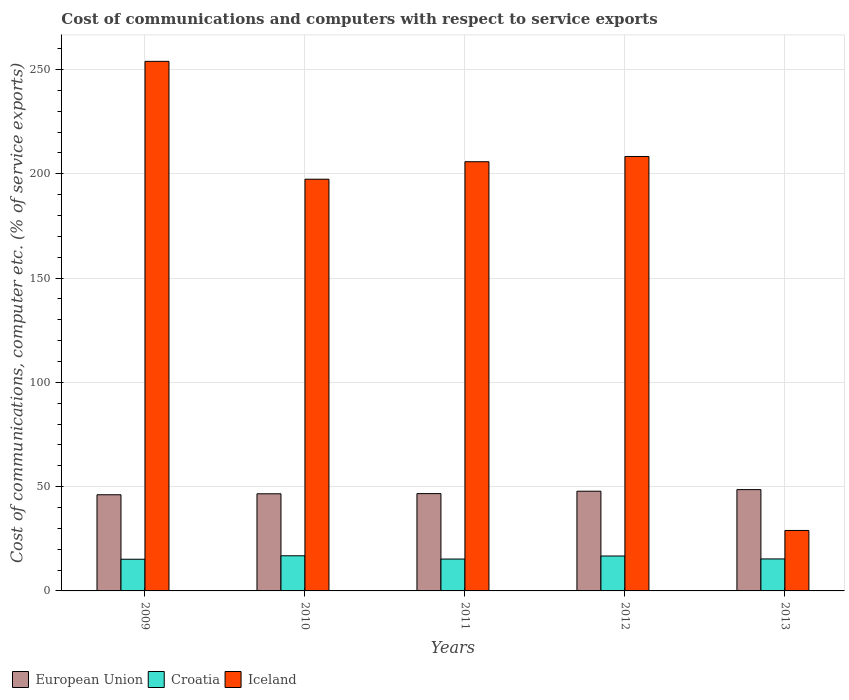How many different coloured bars are there?
Provide a short and direct response. 3. How many groups of bars are there?
Your answer should be very brief. 5. How many bars are there on the 5th tick from the left?
Your answer should be very brief. 3. What is the label of the 5th group of bars from the left?
Provide a short and direct response. 2013. What is the cost of communications and computers in Iceland in 2011?
Ensure brevity in your answer.  205.78. Across all years, what is the maximum cost of communications and computers in Iceland?
Keep it short and to the point. 253.9. Across all years, what is the minimum cost of communications and computers in Iceland?
Offer a very short reply. 28.99. In which year was the cost of communications and computers in Croatia minimum?
Offer a terse response. 2009. What is the total cost of communications and computers in European Union in the graph?
Provide a short and direct response. 235.71. What is the difference between the cost of communications and computers in European Union in 2010 and that in 2012?
Provide a short and direct response. -1.24. What is the difference between the cost of communications and computers in Iceland in 2010 and the cost of communications and computers in Croatia in 2009?
Ensure brevity in your answer.  182.21. What is the average cost of communications and computers in Croatia per year?
Your response must be concise. 15.88. In the year 2012, what is the difference between the cost of communications and computers in Iceland and cost of communications and computers in Croatia?
Provide a succinct answer. 191.56. What is the ratio of the cost of communications and computers in Croatia in 2010 to that in 2012?
Give a very brief answer. 1.01. Is the difference between the cost of communications and computers in Iceland in 2010 and 2011 greater than the difference between the cost of communications and computers in Croatia in 2010 and 2011?
Keep it short and to the point. No. What is the difference between the highest and the second highest cost of communications and computers in Croatia?
Give a very brief answer. 0.11. What is the difference between the highest and the lowest cost of communications and computers in Croatia?
Offer a terse response. 1.66. What does the 2nd bar from the right in 2011 represents?
Keep it short and to the point. Croatia. How many bars are there?
Offer a very short reply. 15. Are all the bars in the graph horizontal?
Your answer should be very brief. No. How many years are there in the graph?
Offer a terse response. 5. Does the graph contain any zero values?
Provide a short and direct response. No. How many legend labels are there?
Your answer should be compact. 3. What is the title of the graph?
Give a very brief answer. Cost of communications and computers with respect to service exports. Does "Madagascar" appear as one of the legend labels in the graph?
Your response must be concise. No. What is the label or title of the Y-axis?
Provide a short and direct response. Cost of communications, computer etc. (% of service exports). What is the Cost of communications, computer etc. (% of service exports) of European Union in 2009?
Provide a succinct answer. 46.11. What is the Cost of communications, computer etc. (% of service exports) in Croatia in 2009?
Your answer should be compact. 15.19. What is the Cost of communications, computer etc. (% of service exports) of Iceland in 2009?
Your response must be concise. 253.9. What is the Cost of communications, computer etc. (% of service exports) of European Union in 2010?
Offer a terse response. 46.57. What is the Cost of communications, computer etc. (% of service exports) of Croatia in 2010?
Give a very brief answer. 16.85. What is the Cost of communications, computer etc. (% of service exports) in Iceland in 2010?
Keep it short and to the point. 197.4. What is the Cost of communications, computer etc. (% of service exports) in European Union in 2011?
Offer a terse response. 46.65. What is the Cost of communications, computer etc. (% of service exports) in Croatia in 2011?
Ensure brevity in your answer.  15.28. What is the Cost of communications, computer etc. (% of service exports) in Iceland in 2011?
Keep it short and to the point. 205.78. What is the Cost of communications, computer etc. (% of service exports) of European Union in 2012?
Your answer should be very brief. 47.81. What is the Cost of communications, computer etc. (% of service exports) in Croatia in 2012?
Keep it short and to the point. 16.74. What is the Cost of communications, computer etc. (% of service exports) of Iceland in 2012?
Your answer should be compact. 208.3. What is the Cost of communications, computer etc. (% of service exports) in European Union in 2013?
Give a very brief answer. 48.57. What is the Cost of communications, computer etc. (% of service exports) in Croatia in 2013?
Ensure brevity in your answer.  15.34. What is the Cost of communications, computer etc. (% of service exports) in Iceland in 2013?
Your response must be concise. 28.99. Across all years, what is the maximum Cost of communications, computer etc. (% of service exports) in European Union?
Your answer should be very brief. 48.57. Across all years, what is the maximum Cost of communications, computer etc. (% of service exports) of Croatia?
Your response must be concise. 16.85. Across all years, what is the maximum Cost of communications, computer etc. (% of service exports) in Iceland?
Give a very brief answer. 253.9. Across all years, what is the minimum Cost of communications, computer etc. (% of service exports) in European Union?
Provide a short and direct response. 46.11. Across all years, what is the minimum Cost of communications, computer etc. (% of service exports) in Croatia?
Keep it short and to the point. 15.19. Across all years, what is the minimum Cost of communications, computer etc. (% of service exports) in Iceland?
Offer a terse response. 28.99. What is the total Cost of communications, computer etc. (% of service exports) in European Union in the graph?
Keep it short and to the point. 235.71. What is the total Cost of communications, computer etc. (% of service exports) in Croatia in the graph?
Provide a short and direct response. 79.39. What is the total Cost of communications, computer etc. (% of service exports) in Iceland in the graph?
Give a very brief answer. 894.36. What is the difference between the Cost of communications, computer etc. (% of service exports) in European Union in 2009 and that in 2010?
Offer a terse response. -0.46. What is the difference between the Cost of communications, computer etc. (% of service exports) of Croatia in 2009 and that in 2010?
Your response must be concise. -1.66. What is the difference between the Cost of communications, computer etc. (% of service exports) of Iceland in 2009 and that in 2010?
Offer a terse response. 56.51. What is the difference between the Cost of communications, computer etc. (% of service exports) of European Union in 2009 and that in 2011?
Give a very brief answer. -0.54. What is the difference between the Cost of communications, computer etc. (% of service exports) of Croatia in 2009 and that in 2011?
Ensure brevity in your answer.  -0.09. What is the difference between the Cost of communications, computer etc. (% of service exports) in Iceland in 2009 and that in 2011?
Your response must be concise. 48.12. What is the difference between the Cost of communications, computer etc. (% of service exports) of European Union in 2009 and that in 2012?
Your answer should be very brief. -1.7. What is the difference between the Cost of communications, computer etc. (% of service exports) of Croatia in 2009 and that in 2012?
Your answer should be compact. -1.55. What is the difference between the Cost of communications, computer etc. (% of service exports) in Iceland in 2009 and that in 2012?
Ensure brevity in your answer.  45.6. What is the difference between the Cost of communications, computer etc. (% of service exports) of European Union in 2009 and that in 2013?
Your response must be concise. -2.46. What is the difference between the Cost of communications, computer etc. (% of service exports) in Croatia in 2009 and that in 2013?
Provide a succinct answer. -0.15. What is the difference between the Cost of communications, computer etc. (% of service exports) in Iceland in 2009 and that in 2013?
Offer a terse response. 224.91. What is the difference between the Cost of communications, computer etc. (% of service exports) in European Union in 2010 and that in 2011?
Provide a short and direct response. -0.08. What is the difference between the Cost of communications, computer etc. (% of service exports) in Croatia in 2010 and that in 2011?
Your response must be concise. 1.58. What is the difference between the Cost of communications, computer etc. (% of service exports) in Iceland in 2010 and that in 2011?
Your answer should be compact. -8.38. What is the difference between the Cost of communications, computer etc. (% of service exports) of European Union in 2010 and that in 2012?
Give a very brief answer. -1.24. What is the difference between the Cost of communications, computer etc. (% of service exports) of Croatia in 2010 and that in 2012?
Make the answer very short. 0.11. What is the difference between the Cost of communications, computer etc. (% of service exports) in Iceland in 2010 and that in 2012?
Provide a succinct answer. -10.9. What is the difference between the Cost of communications, computer etc. (% of service exports) of European Union in 2010 and that in 2013?
Ensure brevity in your answer.  -1.99. What is the difference between the Cost of communications, computer etc. (% of service exports) of Croatia in 2010 and that in 2013?
Give a very brief answer. 1.52. What is the difference between the Cost of communications, computer etc. (% of service exports) in Iceland in 2010 and that in 2013?
Keep it short and to the point. 168.41. What is the difference between the Cost of communications, computer etc. (% of service exports) in European Union in 2011 and that in 2012?
Provide a short and direct response. -1.16. What is the difference between the Cost of communications, computer etc. (% of service exports) of Croatia in 2011 and that in 2012?
Your answer should be compact. -1.46. What is the difference between the Cost of communications, computer etc. (% of service exports) of Iceland in 2011 and that in 2012?
Your response must be concise. -2.52. What is the difference between the Cost of communications, computer etc. (% of service exports) of European Union in 2011 and that in 2013?
Provide a short and direct response. -1.92. What is the difference between the Cost of communications, computer etc. (% of service exports) of Croatia in 2011 and that in 2013?
Make the answer very short. -0.06. What is the difference between the Cost of communications, computer etc. (% of service exports) in Iceland in 2011 and that in 2013?
Offer a terse response. 176.79. What is the difference between the Cost of communications, computer etc. (% of service exports) of European Union in 2012 and that in 2013?
Your response must be concise. -0.76. What is the difference between the Cost of communications, computer etc. (% of service exports) in Croatia in 2012 and that in 2013?
Offer a terse response. 1.4. What is the difference between the Cost of communications, computer etc. (% of service exports) of Iceland in 2012 and that in 2013?
Provide a short and direct response. 179.31. What is the difference between the Cost of communications, computer etc. (% of service exports) of European Union in 2009 and the Cost of communications, computer etc. (% of service exports) of Croatia in 2010?
Offer a very short reply. 29.26. What is the difference between the Cost of communications, computer etc. (% of service exports) of European Union in 2009 and the Cost of communications, computer etc. (% of service exports) of Iceland in 2010?
Your answer should be very brief. -151.29. What is the difference between the Cost of communications, computer etc. (% of service exports) of Croatia in 2009 and the Cost of communications, computer etc. (% of service exports) of Iceland in 2010?
Keep it short and to the point. -182.21. What is the difference between the Cost of communications, computer etc. (% of service exports) in European Union in 2009 and the Cost of communications, computer etc. (% of service exports) in Croatia in 2011?
Give a very brief answer. 30.83. What is the difference between the Cost of communications, computer etc. (% of service exports) of European Union in 2009 and the Cost of communications, computer etc. (% of service exports) of Iceland in 2011?
Offer a terse response. -159.67. What is the difference between the Cost of communications, computer etc. (% of service exports) in Croatia in 2009 and the Cost of communications, computer etc. (% of service exports) in Iceland in 2011?
Offer a terse response. -190.59. What is the difference between the Cost of communications, computer etc. (% of service exports) in European Union in 2009 and the Cost of communications, computer etc. (% of service exports) in Croatia in 2012?
Make the answer very short. 29.37. What is the difference between the Cost of communications, computer etc. (% of service exports) of European Union in 2009 and the Cost of communications, computer etc. (% of service exports) of Iceland in 2012?
Keep it short and to the point. -162.19. What is the difference between the Cost of communications, computer etc. (% of service exports) in Croatia in 2009 and the Cost of communications, computer etc. (% of service exports) in Iceland in 2012?
Your answer should be very brief. -193.11. What is the difference between the Cost of communications, computer etc. (% of service exports) of European Union in 2009 and the Cost of communications, computer etc. (% of service exports) of Croatia in 2013?
Give a very brief answer. 30.77. What is the difference between the Cost of communications, computer etc. (% of service exports) of European Union in 2009 and the Cost of communications, computer etc. (% of service exports) of Iceland in 2013?
Provide a succinct answer. 17.12. What is the difference between the Cost of communications, computer etc. (% of service exports) in Croatia in 2009 and the Cost of communications, computer etc. (% of service exports) in Iceland in 2013?
Your answer should be compact. -13.8. What is the difference between the Cost of communications, computer etc. (% of service exports) of European Union in 2010 and the Cost of communications, computer etc. (% of service exports) of Croatia in 2011?
Offer a very short reply. 31.3. What is the difference between the Cost of communications, computer etc. (% of service exports) of European Union in 2010 and the Cost of communications, computer etc. (% of service exports) of Iceland in 2011?
Offer a very short reply. -159.2. What is the difference between the Cost of communications, computer etc. (% of service exports) of Croatia in 2010 and the Cost of communications, computer etc. (% of service exports) of Iceland in 2011?
Your answer should be compact. -188.92. What is the difference between the Cost of communications, computer etc. (% of service exports) of European Union in 2010 and the Cost of communications, computer etc. (% of service exports) of Croatia in 2012?
Your response must be concise. 29.83. What is the difference between the Cost of communications, computer etc. (% of service exports) of European Union in 2010 and the Cost of communications, computer etc. (% of service exports) of Iceland in 2012?
Your answer should be very brief. -161.72. What is the difference between the Cost of communications, computer etc. (% of service exports) in Croatia in 2010 and the Cost of communications, computer etc. (% of service exports) in Iceland in 2012?
Offer a terse response. -191.45. What is the difference between the Cost of communications, computer etc. (% of service exports) in European Union in 2010 and the Cost of communications, computer etc. (% of service exports) in Croatia in 2013?
Ensure brevity in your answer.  31.24. What is the difference between the Cost of communications, computer etc. (% of service exports) in European Union in 2010 and the Cost of communications, computer etc. (% of service exports) in Iceland in 2013?
Your answer should be very brief. 17.58. What is the difference between the Cost of communications, computer etc. (% of service exports) in Croatia in 2010 and the Cost of communications, computer etc. (% of service exports) in Iceland in 2013?
Your answer should be very brief. -12.14. What is the difference between the Cost of communications, computer etc. (% of service exports) in European Union in 2011 and the Cost of communications, computer etc. (% of service exports) in Croatia in 2012?
Offer a terse response. 29.91. What is the difference between the Cost of communications, computer etc. (% of service exports) in European Union in 2011 and the Cost of communications, computer etc. (% of service exports) in Iceland in 2012?
Ensure brevity in your answer.  -161.65. What is the difference between the Cost of communications, computer etc. (% of service exports) in Croatia in 2011 and the Cost of communications, computer etc. (% of service exports) in Iceland in 2012?
Provide a short and direct response. -193.02. What is the difference between the Cost of communications, computer etc. (% of service exports) of European Union in 2011 and the Cost of communications, computer etc. (% of service exports) of Croatia in 2013?
Ensure brevity in your answer.  31.32. What is the difference between the Cost of communications, computer etc. (% of service exports) of European Union in 2011 and the Cost of communications, computer etc. (% of service exports) of Iceland in 2013?
Make the answer very short. 17.66. What is the difference between the Cost of communications, computer etc. (% of service exports) of Croatia in 2011 and the Cost of communications, computer etc. (% of service exports) of Iceland in 2013?
Make the answer very short. -13.71. What is the difference between the Cost of communications, computer etc. (% of service exports) in European Union in 2012 and the Cost of communications, computer etc. (% of service exports) in Croatia in 2013?
Ensure brevity in your answer.  32.47. What is the difference between the Cost of communications, computer etc. (% of service exports) of European Union in 2012 and the Cost of communications, computer etc. (% of service exports) of Iceland in 2013?
Ensure brevity in your answer.  18.82. What is the difference between the Cost of communications, computer etc. (% of service exports) in Croatia in 2012 and the Cost of communications, computer etc. (% of service exports) in Iceland in 2013?
Your response must be concise. -12.25. What is the average Cost of communications, computer etc. (% of service exports) of European Union per year?
Give a very brief answer. 47.14. What is the average Cost of communications, computer etc. (% of service exports) in Croatia per year?
Ensure brevity in your answer.  15.88. What is the average Cost of communications, computer etc. (% of service exports) of Iceland per year?
Your response must be concise. 178.87. In the year 2009, what is the difference between the Cost of communications, computer etc. (% of service exports) in European Union and Cost of communications, computer etc. (% of service exports) in Croatia?
Keep it short and to the point. 30.92. In the year 2009, what is the difference between the Cost of communications, computer etc. (% of service exports) in European Union and Cost of communications, computer etc. (% of service exports) in Iceland?
Ensure brevity in your answer.  -207.79. In the year 2009, what is the difference between the Cost of communications, computer etc. (% of service exports) of Croatia and Cost of communications, computer etc. (% of service exports) of Iceland?
Your response must be concise. -238.71. In the year 2010, what is the difference between the Cost of communications, computer etc. (% of service exports) of European Union and Cost of communications, computer etc. (% of service exports) of Croatia?
Offer a very short reply. 29.72. In the year 2010, what is the difference between the Cost of communications, computer etc. (% of service exports) of European Union and Cost of communications, computer etc. (% of service exports) of Iceland?
Offer a very short reply. -150.82. In the year 2010, what is the difference between the Cost of communications, computer etc. (% of service exports) of Croatia and Cost of communications, computer etc. (% of service exports) of Iceland?
Give a very brief answer. -180.54. In the year 2011, what is the difference between the Cost of communications, computer etc. (% of service exports) of European Union and Cost of communications, computer etc. (% of service exports) of Croatia?
Provide a succinct answer. 31.38. In the year 2011, what is the difference between the Cost of communications, computer etc. (% of service exports) in European Union and Cost of communications, computer etc. (% of service exports) in Iceland?
Offer a very short reply. -159.12. In the year 2011, what is the difference between the Cost of communications, computer etc. (% of service exports) of Croatia and Cost of communications, computer etc. (% of service exports) of Iceland?
Your answer should be compact. -190.5. In the year 2012, what is the difference between the Cost of communications, computer etc. (% of service exports) of European Union and Cost of communications, computer etc. (% of service exports) of Croatia?
Your response must be concise. 31.07. In the year 2012, what is the difference between the Cost of communications, computer etc. (% of service exports) in European Union and Cost of communications, computer etc. (% of service exports) in Iceland?
Your answer should be very brief. -160.49. In the year 2012, what is the difference between the Cost of communications, computer etc. (% of service exports) of Croatia and Cost of communications, computer etc. (% of service exports) of Iceland?
Provide a short and direct response. -191.56. In the year 2013, what is the difference between the Cost of communications, computer etc. (% of service exports) of European Union and Cost of communications, computer etc. (% of service exports) of Croatia?
Offer a terse response. 33.23. In the year 2013, what is the difference between the Cost of communications, computer etc. (% of service exports) in European Union and Cost of communications, computer etc. (% of service exports) in Iceland?
Provide a short and direct response. 19.58. In the year 2013, what is the difference between the Cost of communications, computer etc. (% of service exports) in Croatia and Cost of communications, computer etc. (% of service exports) in Iceland?
Offer a very short reply. -13.65. What is the ratio of the Cost of communications, computer etc. (% of service exports) in European Union in 2009 to that in 2010?
Your response must be concise. 0.99. What is the ratio of the Cost of communications, computer etc. (% of service exports) of Croatia in 2009 to that in 2010?
Keep it short and to the point. 0.9. What is the ratio of the Cost of communications, computer etc. (% of service exports) in Iceland in 2009 to that in 2010?
Your response must be concise. 1.29. What is the ratio of the Cost of communications, computer etc. (% of service exports) of European Union in 2009 to that in 2011?
Ensure brevity in your answer.  0.99. What is the ratio of the Cost of communications, computer etc. (% of service exports) of Croatia in 2009 to that in 2011?
Your answer should be compact. 0.99. What is the ratio of the Cost of communications, computer etc. (% of service exports) in Iceland in 2009 to that in 2011?
Offer a terse response. 1.23. What is the ratio of the Cost of communications, computer etc. (% of service exports) of European Union in 2009 to that in 2012?
Your answer should be compact. 0.96. What is the ratio of the Cost of communications, computer etc. (% of service exports) in Croatia in 2009 to that in 2012?
Provide a short and direct response. 0.91. What is the ratio of the Cost of communications, computer etc. (% of service exports) of Iceland in 2009 to that in 2012?
Offer a very short reply. 1.22. What is the ratio of the Cost of communications, computer etc. (% of service exports) of European Union in 2009 to that in 2013?
Your response must be concise. 0.95. What is the ratio of the Cost of communications, computer etc. (% of service exports) of Iceland in 2009 to that in 2013?
Offer a very short reply. 8.76. What is the ratio of the Cost of communications, computer etc. (% of service exports) of Croatia in 2010 to that in 2011?
Ensure brevity in your answer.  1.1. What is the ratio of the Cost of communications, computer etc. (% of service exports) of Iceland in 2010 to that in 2011?
Provide a short and direct response. 0.96. What is the ratio of the Cost of communications, computer etc. (% of service exports) in European Union in 2010 to that in 2012?
Offer a terse response. 0.97. What is the ratio of the Cost of communications, computer etc. (% of service exports) in Croatia in 2010 to that in 2012?
Give a very brief answer. 1.01. What is the ratio of the Cost of communications, computer etc. (% of service exports) in Iceland in 2010 to that in 2012?
Your answer should be compact. 0.95. What is the ratio of the Cost of communications, computer etc. (% of service exports) of European Union in 2010 to that in 2013?
Your answer should be very brief. 0.96. What is the ratio of the Cost of communications, computer etc. (% of service exports) in Croatia in 2010 to that in 2013?
Provide a short and direct response. 1.1. What is the ratio of the Cost of communications, computer etc. (% of service exports) of Iceland in 2010 to that in 2013?
Ensure brevity in your answer.  6.81. What is the ratio of the Cost of communications, computer etc. (% of service exports) in European Union in 2011 to that in 2012?
Give a very brief answer. 0.98. What is the ratio of the Cost of communications, computer etc. (% of service exports) of Croatia in 2011 to that in 2012?
Provide a short and direct response. 0.91. What is the ratio of the Cost of communications, computer etc. (% of service exports) in Iceland in 2011 to that in 2012?
Your answer should be very brief. 0.99. What is the ratio of the Cost of communications, computer etc. (% of service exports) in European Union in 2011 to that in 2013?
Ensure brevity in your answer.  0.96. What is the ratio of the Cost of communications, computer etc. (% of service exports) in Iceland in 2011 to that in 2013?
Provide a short and direct response. 7.1. What is the ratio of the Cost of communications, computer etc. (% of service exports) of European Union in 2012 to that in 2013?
Your answer should be compact. 0.98. What is the ratio of the Cost of communications, computer etc. (% of service exports) in Croatia in 2012 to that in 2013?
Offer a very short reply. 1.09. What is the ratio of the Cost of communications, computer etc. (% of service exports) in Iceland in 2012 to that in 2013?
Your answer should be very brief. 7.19. What is the difference between the highest and the second highest Cost of communications, computer etc. (% of service exports) in European Union?
Offer a very short reply. 0.76. What is the difference between the highest and the second highest Cost of communications, computer etc. (% of service exports) of Croatia?
Make the answer very short. 0.11. What is the difference between the highest and the second highest Cost of communications, computer etc. (% of service exports) of Iceland?
Offer a very short reply. 45.6. What is the difference between the highest and the lowest Cost of communications, computer etc. (% of service exports) of European Union?
Provide a short and direct response. 2.46. What is the difference between the highest and the lowest Cost of communications, computer etc. (% of service exports) of Croatia?
Your answer should be compact. 1.66. What is the difference between the highest and the lowest Cost of communications, computer etc. (% of service exports) of Iceland?
Keep it short and to the point. 224.91. 